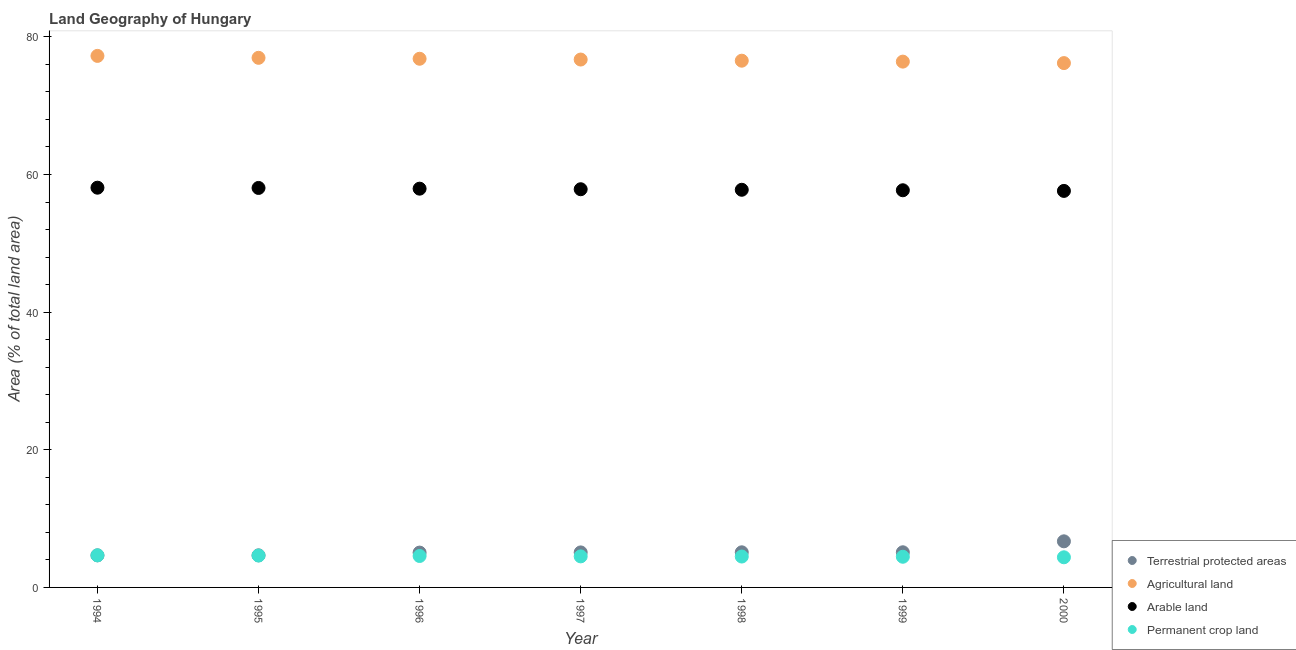How many different coloured dotlines are there?
Ensure brevity in your answer.  4. What is the percentage of land under terrestrial protection in 1996?
Your answer should be very brief. 5.06. Across all years, what is the maximum percentage of land under terrestrial protection?
Give a very brief answer. 6.7. Across all years, what is the minimum percentage of area under permanent crop land?
Your response must be concise. 4.38. What is the total percentage of area under agricultural land in the graph?
Offer a terse response. 536.87. What is the difference between the percentage of area under arable land in 1994 and that in 1996?
Your answer should be compact. 0.14. What is the difference between the percentage of area under arable land in 1994 and the percentage of area under permanent crop land in 2000?
Offer a very short reply. 53.71. What is the average percentage of area under agricultural land per year?
Ensure brevity in your answer.  76.7. In the year 1996, what is the difference between the percentage of land under terrestrial protection and percentage of area under agricultural land?
Provide a short and direct response. -71.76. What is the ratio of the percentage of area under permanent crop land in 1994 to that in 1998?
Make the answer very short. 1.04. What is the difference between the highest and the second highest percentage of area under arable land?
Your answer should be very brief. 0.04. What is the difference between the highest and the lowest percentage of land under terrestrial protection?
Your answer should be very brief. 2.04. In how many years, is the percentage of area under permanent crop land greater than the average percentage of area under permanent crop land taken over all years?
Your response must be concise. 3. Is the sum of the percentage of area under agricultural land in 1995 and 2000 greater than the maximum percentage of area under arable land across all years?
Make the answer very short. Yes. Is the percentage of land under terrestrial protection strictly greater than the percentage of area under permanent crop land over the years?
Ensure brevity in your answer.  No. Is the percentage of land under terrestrial protection strictly less than the percentage of area under permanent crop land over the years?
Give a very brief answer. No. What is the difference between two consecutive major ticks on the Y-axis?
Offer a very short reply. 20. How are the legend labels stacked?
Make the answer very short. Vertical. What is the title of the graph?
Your answer should be very brief. Land Geography of Hungary. What is the label or title of the Y-axis?
Make the answer very short. Area (% of total land area). What is the Area (% of total land area) of Terrestrial protected areas in 1994?
Ensure brevity in your answer.  4.66. What is the Area (% of total land area) in Agricultural land in 1994?
Your response must be concise. 77.24. What is the Area (% of total land area) in Arable land in 1994?
Your response must be concise. 58.09. What is the Area (% of total land area) in Permanent crop land in 1994?
Offer a terse response. 4.67. What is the Area (% of total land area) of Terrestrial protected areas in 1995?
Ensure brevity in your answer.  4.66. What is the Area (% of total land area) in Agricultural land in 1995?
Offer a terse response. 76.96. What is the Area (% of total land area) in Arable land in 1995?
Make the answer very short. 58.05. What is the Area (% of total land area) in Permanent crop land in 1995?
Keep it short and to the point. 4.63. What is the Area (% of total land area) in Terrestrial protected areas in 1996?
Give a very brief answer. 5.06. What is the Area (% of total land area) of Agricultural land in 1996?
Offer a very short reply. 76.82. What is the Area (% of total land area) in Arable land in 1996?
Your response must be concise. 57.94. What is the Area (% of total land area) of Permanent crop land in 1996?
Ensure brevity in your answer.  4.57. What is the Area (% of total land area) of Terrestrial protected areas in 1997?
Offer a very short reply. 5.09. What is the Area (% of total land area) of Agricultural land in 1997?
Provide a succinct answer. 76.71. What is the Area (% of total land area) of Arable land in 1997?
Keep it short and to the point. 57.86. What is the Area (% of total land area) of Permanent crop land in 1997?
Make the answer very short. 4.51. What is the Area (% of total land area) of Terrestrial protected areas in 1998?
Ensure brevity in your answer.  5.1. What is the Area (% of total land area) in Agricultural land in 1998?
Give a very brief answer. 76.54. What is the Area (% of total land area) in Arable land in 1998?
Offer a terse response. 57.78. What is the Area (% of total land area) in Permanent crop land in 1998?
Offer a terse response. 4.49. What is the Area (% of total land area) in Terrestrial protected areas in 1999?
Ensure brevity in your answer.  5.11. What is the Area (% of total land area) of Agricultural land in 1999?
Provide a short and direct response. 76.41. What is the Area (% of total land area) of Arable land in 1999?
Keep it short and to the point. 57.71. What is the Area (% of total land area) in Permanent crop land in 1999?
Provide a succinct answer. 4.46. What is the Area (% of total land area) of Terrestrial protected areas in 2000?
Ensure brevity in your answer.  6.7. What is the Area (% of total land area) of Agricultural land in 2000?
Ensure brevity in your answer.  76.19. What is the Area (% of total land area) in Arable land in 2000?
Offer a terse response. 57.62. What is the Area (% of total land area) in Permanent crop land in 2000?
Make the answer very short. 4.38. Across all years, what is the maximum Area (% of total land area) of Terrestrial protected areas?
Offer a very short reply. 6.7. Across all years, what is the maximum Area (% of total land area) of Agricultural land?
Your response must be concise. 77.24. Across all years, what is the maximum Area (% of total land area) of Arable land?
Keep it short and to the point. 58.09. Across all years, what is the maximum Area (% of total land area) of Permanent crop land?
Keep it short and to the point. 4.67. Across all years, what is the minimum Area (% of total land area) of Terrestrial protected areas?
Give a very brief answer. 4.66. Across all years, what is the minimum Area (% of total land area) of Agricultural land?
Make the answer very short. 76.19. Across all years, what is the minimum Area (% of total land area) of Arable land?
Your answer should be very brief. 57.62. Across all years, what is the minimum Area (% of total land area) of Permanent crop land?
Ensure brevity in your answer.  4.38. What is the total Area (% of total land area) in Terrestrial protected areas in the graph?
Offer a terse response. 36.39. What is the total Area (% of total land area) in Agricultural land in the graph?
Your answer should be very brief. 536.87. What is the total Area (% of total land area) in Arable land in the graph?
Keep it short and to the point. 405.06. What is the total Area (% of total land area) in Permanent crop land in the graph?
Provide a short and direct response. 31.7. What is the difference between the Area (% of total land area) in Terrestrial protected areas in 1994 and that in 1995?
Your response must be concise. -0. What is the difference between the Area (% of total land area) of Agricultural land in 1994 and that in 1995?
Offer a very short reply. 0.28. What is the difference between the Area (% of total land area) in Arable land in 1994 and that in 1995?
Your answer should be compact. 0.04. What is the difference between the Area (% of total land area) of Permanent crop land in 1994 and that in 1995?
Make the answer very short. 0.03. What is the difference between the Area (% of total land area) in Terrestrial protected areas in 1994 and that in 1996?
Provide a succinct answer. -0.4. What is the difference between the Area (% of total land area) of Agricultural land in 1994 and that in 1996?
Ensure brevity in your answer.  0.42. What is the difference between the Area (% of total land area) in Arable land in 1994 and that in 1996?
Keep it short and to the point. 0.14. What is the difference between the Area (% of total land area) of Permanent crop land in 1994 and that in 1996?
Give a very brief answer. 0.1. What is the difference between the Area (% of total land area) of Terrestrial protected areas in 1994 and that in 1997?
Make the answer very short. -0.43. What is the difference between the Area (% of total land area) of Agricultural land in 1994 and that in 1997?
Make the answer very short. 0.53. What is the difference between the Area (% of total land area) of Arable land in 1994 and that in 1997?
Offer a terse response. 0.23. What is the difference between the Area (% of total land area) of Permanent crop land in 1994 and that in 1997?
Your answer should be compact. 0.15. What is the difference between the Area (% of total land area) in Terrestrial protected areas in 1994 and that in 1998?
Offer a terse response. -0.44. What is the difference between the Area (% of total land area) of Agricultural land in 1994 and that in 1998?
Your answer should be compact. 0.7. What is the difference between the Area (% of total land area) in Arable land in 1994 and that in 1998?
Offer a terse response. 0.3. What is the difference between the Area (% of total land area) in Permanent crop land in 1994 and that in 1998?
Your answer should be compact. 0.18. What is the difference between the Area (% of total land area) of Terrestrial protected areas in 1994 and that in 1999?
Keep it short and to the point. -0.45. What is the difference between the Area (% of total land area) in Agricultural land in 1994 and that in 1999?
Keep it short and to the point. 0.83. What is the difference between the Area (% of total land area) of Arable land in 1994 and that in 1999?
Offer a very short reply. 0.37. What is the difference between the Area (% of total land area) of Permanent crop land in 1994 and that in 1999?
Offer a terse response. 0.21. What is the difference between the Area (% of total land area) in Terrestrial protected areas in 1994 and that in 2000?
Your answer should be very brief. -2.04. What is the difference between the Area (% of total land area) in Agricultural land in 1994 and that in 2000?
Offer a terse response. 1.05. What is the difference between the Area (% of total land area) in Arable land in 1994 and that in 2000?
Your response must be concise. 0.47. What is the difference between the Area (% of total land area) of Permanent crop land in 1994 and that in 2000?
Offer a terse response. 0.29. What is the difference between the Area (% of total land area) in Terrestrial protected areas in 1995 and that in 1996?
Provide a short and direct response. -0.4. What is the difference between the Area (% of total land area) in Agricultural land in 1995 and that in 1996?
Provide a short and direct response. 0.14. What is the difference between the Area (% of total land area) of Arable land in 1995 and that in 1996?
Your response must be concise. 0.1. What is the difference between the Area (% of total land area) of Permanent crop land in 1995 and that in 1996?
Keep it short and to the point. 0.07. What is the difference between the Area (% of total land area) in Terrestrial protected areas in 1995 and that in 1997?
Make the answer very short. -0.43. What is the difference between the Area (% of total land area) in Agricultural land in 1995 and that in 1997?
Keep it short and to the point. 0.25. What is the difference between the Area (% of total land area) of Arable land in 1995 and that in 1997?
Offer a very short reply. 0.19. What is the difference between the Area (% of total land area) of Permanent crop land in 1995 and that in 1997?
Offer a very short reply. 0.12. What is the difference between the Area (% of total land area) in Terrestrial protected areas in 1995 and that in 1998?
Ensure brevity in your answer.  -0.44. What is the difference between the Area (% of total land area) in Agricultural land in 1995 and that in 1998?
Offer a terse response. 0.42. What is the difference between the Area (% of total land area) in Arable land in 1995 and that in 1998?
Your answer should be very brief. 0.26. What is the difference between the Area (% of total land area) in Permanent crop land in 1995 and that in 1998?
Make the answer very short. 0.14. What is the difference between the Area (% of total land area) of Terrestrial protected areas in 1995 and that in 1999?
Your answer should be very brief. -0.44. What is the difference between the Area (% of total land area) of Agricultural land in 1995 and that in 1999?
Offer a very short reply. 0.55. What is the difference between the Area (% of total land area) of Arable land in 1995 and that in 1999?
Ensure brevity in your answer.  0.34. What is the difference between the Area (% of total land area) of Permanent crop land in 1995 and that in 1999?
Offer a terse response. 0.18. What is the difference between the Area (% of total land area) in Terrestrial protected areas in 1995 and that in 2000?
Offer a very short reply. -2.04. What is the difference between the Area (% of total land area) of Agricultural land in 1995 and that in 2000?
Offer a very short reply. 0.77. What is the difference between the Area (% of total land area) in Arable land in 1995 and that in 2000?
Your answer should be compact. 0.43. What is the difference between the Area (% of total land area) in Permanent crop land in 1995 and that in 2000?
Make the answer very short. 0.25. What is the difference between the Area (% of total land area) in Terrestrial protected areas in 1996 and that in 1997?
Make the answer very short. -0.03. What is the difference between the Area (% of total land area) in Agricultural land in 1996 and that in 1997?
Your answer should be very brief. 0.11. What is the difference between the Area (% of total land area) in Arable land in 1996 and that in 1997?
Ensure brevity in your answer.  0.08. What is the difference between the Area (% of total land area) of Permanent crop land in 1996 and that in 1997?
Make the answer very short. 0.06. What is the difference between the Area (% of total land area) of Terrestrial protected areas in 1996 and that in 1998?
Offer a very short reply. -0.04. What is the difference between the Area (% of total land area) of Agricultural land in 1996 and that in 1998?
Your answer should be very brief. 0.28. What is the difference between the Area (% of total land area) of Arable land in 1996 and that in 1998?
Your answer should be very brief. 0.16. What is the difference between the Area (% of total land area) in Permanent crop land in 1996 and that in 1998?
Offer a very short reply. 0.08. What is the difference between the Area (% of total land area) of Terrestrial protected areas in 1996 and that in 1999?
Make the answer very short. -0.04. What is the difference between the Area (% of total land area) in Agricultural land in 1996 and that in 1999?
Offer a terse response. 0.42. What is the difference between the Area (% of total land area) in Arable land in 1996 and that in 1999?
Provide a short and direct response. 0.23. What is the difference between the Area (% of total land area) in Permanent crop land in 1996 and that in 1999?
Your answer should be compact. 0.11. What is the difference between the Area (% of total land area) in Terrestrial protected areas in 1996 and that in 2000?
Your answer should be compact. -1.64. What is the difference between the Area (% of total land area) in Agricultural land in 1996 and that in 2000?
Offer a very short reply. 0.63. What is the difference between the Area (% of total land area) in Arable land in 1996 and that in 2000?
Give a very brief answer. 0.33. What is the difference between the Area (% of total land area) of Permanent crop land in 1996 and that in 2000?
Your answer should be compact. 0.19. What is the difference between the Area (% of total land area) in Terrestrial protected areas in 1997 and that in 1998?
Give a very brief answer. -0.01. What is the difference between the Area (% of total land area) in Arable land in 1997 and that in 1998?
Keep it short and to the point. 0.08. What is the difference between the Area (% of total land area) in Permanent crop land in 1997 and that in 1998?
Offer a terse response. 0.02. What is the difference between the Area (% of total land area) of Terrestrial protected areas in 1997 and that in 1999?
Give a very brief answer. -0.02. What is the difference between the Area (% of total land area) of Agricultural land in 1997 and that in 1999?
Give a very brief answer. 0.3. What is the difference between the Area (% of total land area) of Arable land in 1997 and that in 1999?
Your answer should be compact. 0.15. What is the difference between the Area (% of total land area) of Permanent crop land in 1997 and that in 1999?
Your answer should be compact. 0.06. What is the difference between the Area (% of total land area) of Terrestrial protected areas in 1997 and that in 2000?
Give a very brief answer. -1.61. What is the difference between the Area (% of total land area) of Agricultural land in 1997 and that in 2000?
Offer a terse response. 0.52. What is the difference between the Area (% of total land area) in Arable land in 1997 and that in 2000?
Your answer should be compact. 0.24. What is the difference between the Area (% of total land area) of Permanent crop land in 1997 and that in 2000?
Provide a short and direct response. 0.13. What is the difference between the Area (% of total land area) in Terrestrial protected areas in 1998 and that in 1999?
Your answer should be very brief. -0. What is the difference between the Area (% of total land area) of Agricultural land in 1998 and that in 1999?
Ensure brevity in your answer.  0.14. What is the difference between the Area (% of total land area) of Arable land in 1998 and that in 1999?
Offer a very short reply. 0.07. What is the difference between the Area (% of total land area) of Permanent crop land in 1998 and that in 1999?
Your answer should be compact. 0.03. What is the difference between the Area (% of total land area) in Terrestrial protected areas in 1998 and that in 2000?
Make the answer very short. -1.6. What is the difference between the Area (% of total land area) in Agricultural land in 1998 and that in 2000?
Your response must be concise. 0.35. What is the difference between the Area (% of total land area) in Arable land in 1998 and that in 2000?
Provide a succinct answer. 0.17. What is the difference between the Area (% of total land area) in Permanent crop land in 1998 and that in 2000?
Your answer should be very brief. 0.11. What is the difference between the Area (% of total land area) in Terrestrial protected areas in 1999 and that in 2000?
Provide a succinct answer. -1.59. What is the difference between the Area (% of total land area) in Agricultural land in 1999 and that in 2000?
Make the answer very short. 0.21. What is the difference between the Area (% of total land area) of Arable land in 1999 and that in 2000?
Ensure brevity in your answer.  0.09. What is the difference between the Area (% of total land area) in Permanent crop land in 1999 and that in 2000?
Keep it short and to the point. 0.08. What is the difference between the Area (% of total land area) of Terrestrial protected areas in 1994 and the Area (% of total land area) of Agricultural land in 1995?
Your answer should be very brief. -72.3. What is the difference between the Area (% of total land area) of Terrestrial protected areas in 1994 and the Area (% of total land area) of Arable land in 1995?
Offer a terse response. -53.39. What is the difference between the Area (% of total land area) of Terrestrial protected areas in 1994 and the Area (% of total land area) of Permanent crop land in 1995?
Give a very brief answer. 0.03. What is the difference between the Area (% of total land area) in Agricultural land in 1994 and the Area (% of total land area) in Arable land in 1995?
Offer a terse response. 19.19. What is the difference between the Area (% of total land area) in Agricultural land in 1994 and the Area (% of total land area) in Permanent crop land in 1995?
Your answer should be very brief. 72.61. What is the difference between the Area (% of total land area) of Arable land in 1994 and the Area (% of total land area) of Permanent crop land in 1995?
Give a very brief answer. 53.45. What is the difference between the Area (% of total land area) in Terrestrial protected areas in 1994 and the Area (% of total land area) in Agricultural land in 1996?
Provide a succinct answer. -72.16. What is the difference between the Area (% of total land area) in Terrestrial protected areas in 1994 and the Area (% of total land area) in Arable land in 1996?
Keep it short and to the point. -53.28. What is the difference between the Area (% of total land area) of Terrestrial protected areas in 1994 and the Area (% of total land area) of Permanent crop land in 1996?
Keep it short and to the point. 0.09. What is the difference between the Area (% of total land area) of Agricultural land in 1994 and the Area (% of total land area) of Arable land in 1996?
Offer a terse response. 19.29. What is the difference between the Area (% of total land area) in Agricultural land in 1994 and the Area (% of total land area) in Permanent crop land in 1996?
Keep it short and to the point. 72.67. What is the difference between the Area (% of total land area) of Arable land in 1994 and the Area (% of total land area) of Permanent crop land in 1996?
Provide a short and direct response. 53.52. What is the difference between the Area (% of total land area) of Terrestrial protected areas in 1994 and the Area (% of total land area) of Agricultural land in 1997?
Offer a terse response. -72.05. What is the difference between the Area (% of total land area) of Terrestrial protected areas in 1994 and the Area (% of total land area) of Arable land in 1997?
Give a very brief answer. -53.2. What is the difference between the Area (% of total land area) in Terrestrial protected areas in 1994 and the Area (% of total land area) in Permanent crop land in 1997?
Make the answer very short. 0.15. What is the difference between the Area (% of total land area) of Agricultural land in 1994 and the Area (% of total land area) of Arable land in 1997?
Offer a terse response. 19.38. What is the difference between the Area (% of total land area) of Agricultural land in 1994 and the Area (% of total land area) of Permanent crop land in 1997?
Your answer should be very brief. 72.73. What is the difference between the Area (% of total land area) of Arable land in 1994 and the Area (% of total land area) of Permanent crop land in 1997?
Ensure brevity in your answer.  53.58. What is the difference between the Area (% of total land area) in Terrestrial protected areas in 1994 and the Area (% of total land area) in Agricultural land in 1998?
Offer a very short reply. -71.88. What is the difference between the Area (% of total land area) of Terrestrial protected areas in 1994 and the Area (% of total land area) of Arable land in 1998?
Provide a short and direct response. -53.12. What is the difference between the Area (% of total land area) in Terrestrial protected areas in 1994 and the Area (% of total land area) in Permanent crop land in 1998?
Offer a terse response. 0.17. What is the difference between the Area (% of total land area) in Agricultural land in 1994 and the Area (% of total land area) in Arable land in 1998?
Make the answer very short. 19.45. What is the difference between the Area (% of total land area) of Agricultural land in 1994 and the Area (% of total land area) of Permanent crop land in 1998?
Ensure brevity in your answer.  72.75. What is the difference between the Area (% of total land area) of Arable land in 1994 and the Area (% of total land area) of Permanent crop land in 1998?
Offer a terse response. 53.6. What is the difference between the Area (% of total land area) of Terrestrial protected areas in 1994 and the Area (% of total land area) of Agricultural land in 1999?
Provide a succinct answer. -71.74. What is the difference between the Area (% of total land area) of Terrestrial protected areas in 1994 and the Area (% of total land area) of Arable land in 1999?
Your response must be concise. -53.05. What is the difference between the Area (% of total land area) of Terrestrial protected areas in 1994 and the Area (% of total land area) of Permanent crop land in 1999?
Offer a very short reply. 0.2. What is the difference between the Area (% of total land area) of Agricultural land in 1994 and the Area (% of total land area) of Arable land in 1999?
Provide a succinct answer. 19.53. What is the difference between the Area (% of total land area) of Agricultural land in 1994 and the Area (% of total land area) of Permanent crop land in 1999?
Provide a short and direct response. 72.78. What is the difference between the Area (% of total land area) of Arable land in 1994 and the Area (% of total land area) of Permanent crop land in 1999?
Ensure brevity in your answer.  53.63. What is the difference between the Area (% of total land area) in Terrestrial protected areas in 1994 and the Area (% of total land area) in Agricultural land in 2000?
Provide a short and direct response. -71.53. What is the difference between the Area (% of total land area) of Terrestrial protected areas in 1994 and the Area (% of total land area) of Arable land in 2000?
Give a very brief answer. -52.96. What is the difference between the Area (% of total land area) of Terrestrial protected areas in 1994 and the Area (% of total land area) of Permanent crop land in 2000?
Keep it short and to the point. 0.28. What is the difference between the Area (% of total land area) in Agricultural land in 1994 and the Area (% of total land area) in Arable land in 2000?
Offer a terse response. 19.62. What is the difference between the Area (% of total land area) in Agricultural land in 1994 and the Area (% of total land area) in Permanent crop land in 2000?
Give a very brief answer. 72.86. What is the difference between the Area (% of total land area) in Arable land in 1994 and the Area (% of total land area) in Permanent crop land in 2000?
Ensure brevity in your answer.  53.71. What is the difference between the Area (% of total land area) of Terrestrial protected areas in 1995 and the Area (% of total land area) of Agricultural land in 1996?
Ensure brevity in your answer.  -72.16. What is the difference between the Area (% of total land area) in Terrestrial protected areas in 1995 and the Area (% of total land area) in Arable land in 1996?
Offer a terse response. -53.28. What is the difference between the Area (% of total land area) in Terrestrial protected areas in 1995 and the Area (% of total land area) in Permanent crop land in 1996?
Give a very brief answer. 0.1. What is the difference between the Area (% of total land area) in Agricultural land in 1995 and the Area (% of total land area) in Arable land in 1996?
Keep it short and to the point. 19.01. What is the difference between the Area (% of total land area) of Agricultural land in 1995 and the Area (% of total land area) of Permanent crop land in 1996?
Offer a terse response. 72.39. What is the difference between the Area (% of total land area) of Arable land in 1995 and the Area (% of total land area) of Permanent crop land in 1996?
Keep it short and to the point. 53.48. What is the difference between the Area (% of total land area) of Terrestrial protected areas in 1995 and the Area (% of total land area) of Agricultural land in 1997?
Your answer should be very brief. -72.05. What is the difference between the Area (% of total land area) of Terrestrial protected areas in 1995 and the Area (% of total land area) of Arable land in 1997?
Ensure brevity in your answer.  -53.2. What is the difference between the Area (% of total land area) of Terrestrial protected areas in 1995 and the Area (% of total land area) of Permanent crop land in 1997?
Provide a short and direct response. 0.15. What is the difference between the Area (% of total land area) in Agricultural land in 1995 and the Area (% of total land area) in Arable land in 1997?
Your response must be concise. 19.1. What is the difference between the Area (% of total land area) in Agricultural land in 1995 and the Area (% of total land area) in Permanent crop land in 1997?
Provide a short and direct response. 72.45. What is the difference between the Area (% of total land area) of Arable land in 1995 and the Area (% of total land area) of Permanent crop land in 1997?
Your answer should be compact. 53.54. What is the difference between the Area (% of total land area) of Terrestrial protected areas in 1995 and the Area (% of total land area) of Agricultural land in 1998?
Ensure brevity in your answer.  -71.88. What is the difference between the Area (% of total land area) of Terrestrial protected areas in 1995 and the Area (% of total land area) of Arable land in 1998?
Keep it short and to the point. -53.12. What is the difference between the Area (% of total land area) of Terrestrial protected areas in 1995 and the Area (% of total land area) of Permanent crop land in 1998?
Give a very brief answer. 0.17. What is the difference between the Area (% of total land area) of Agricultural land in 1995 and the Area (% of total land area) of Arable land in 1998?
Your answer should be very brief. 19.17. What is the difference between the Area (% of total land area) in Agricultural land in 1995 and the Area (% of total land area) in Permanent crop land in 1998?
Offer a terse response. 72.47. What is the difference between the Area (% of total land area) in Arable land in 1995 and the Area (% of total land area) in Permanent crop land in 1998?
Give a very brief answer. 53.56. What is the difference between the Area (% of total land area) of Terrestrial protected areas in 1995 and the Area (% of total land area) of Agricultural land in 1999?
Your response must be concise. -71.74. What is the difference between the Area (% of total land area) of Terrestrial protected areas in 1995 and the Area (% of total land area) of Arable land in 1999?
Keep it short and to the point. -53.05. What is the difference between the Area (% of total land area) of Terrestrial protected areas in 1995 and the Area (% of total land area) of Permanent crop land in 1999?
Ensure brevity in your answer.  0.21. What is the difference between the Area (% of total land area) of Agricultural land in 1995 and the Area (% of total land area) of Arable land in 1999?
Provide a short and direct response. 19.25. What is the difference between the Area (% of total land area) of Agricultural land in 1995 and the Area (% of total land area) of Permanent crop land in 1999?
Your response must be concise. 72.5. What is the difference between the Area (% of total land area) in Arable land in 1995 and the Area (% of total land area) in Permanent crop land in 1999?
Your answer should be compact. 53.59. What is the difference between the Area (% of total land area) of Terrestrial protected areas in 1995 and the Area (% of total land area) of Agricultural land in 2000?
Keep it short and to the point. -71.53. What is the difference between the Area (% of total land area) in Terrestrial protected areas in 1995 and the Area (% of total land area) in Arable land in 2000?
Make the answer very short. -52.96. What is the difference between the Area (% of total land area) of Terrestrial protected areas in 1995 and the Area (% of total land area) of Permanent crop land in 2000?
Your response must be concise. 0.28. What is the difference between the Area (% of total land area) in Agricultural land in 1995 and the Area (% of total land area) in Arable land in 2000?
Your answer should be very brief. 19.34. What is the difference between the Area (% of total land area) of Agricultural land in 1995 and the Area (% of total land area) of Permanent crop land in 2000?
Make the answer very short. 72.58. What is the difference between the Area (% of total land area) in Arable land in 1995 and the Area (% of total land area) in Permanent crop land in 2000?
Provide a short and direct response. 53.67. What is the difference between the Area (% of total land area) in Terrestrial protected areas in 1996 and the Area (% of total land area) in Agricultural land in 1997?
Keep it short and to the point. -71.65. What is the difference between the Area (% of total land area) of Terrestrial protected areas in 1996 and the Area (% of total land area) of Arable land in 1997?
Provide a short and direct response. -52.8. What is the difference between the Area (% of total land area) of Terrestrial protected areas in 1996 and the Area (% of total land area) of Permanent crop land in 1997?
Provide a succinct answer. 0.55. What is the difference between the Area (% of total land area) of Agricultural land in 1996 and the Area (% of total land area) of Arable land in 1997?
Ensure brevity in your answer.  18.96. What is the difference between the Area (% of total land area) in Agricultural land in 1996 and the Area (% of total land area) in Permanent crop land in 1997?
Ensure brevity in your answer.  72.31. What is the difference between the Area (% of total land area) of Arable land in 1996 and the Area (% of total land area) of Permanent crop land in 1997?
Make the answer very short. 53.43. What is the difference between the Area (% of total land area) in Terrestrial protected areas in 1996 and the Area (% of total land area) in Agricultural land in 1998?
Your answer should be compact. -71.48. What is the difference between the Area (% of total land area) of Terrestrial protected areas in 1996 and the Area (% of total land area) of Arable land in 1998?
Your answer should be compact. -52.72. What is the difference between the Area (% of total land area) of Terrestrial protected areas in 1996 and the Area (% of total land area) of Permanent crop land in 1998?
Your response must be concise. 0.57. What is the difference between the Area (% of total land area) in Agricultural land in 1996 and the Area (% of total land area) in Arable land in 1998?
Give a very brief answer. 19.04. What is the difference between the Area (% of total land area) of Agricultural land in 1996 and the Area (% of total land area) of Permanent crop land in 1998?
Provide a succinct answer. 72.33. What is the difference between the Area (% of total land area) in Arable land in 1996 and the Area (% of total land area) in Permanent crop land in 1998?
Your answer should be compact. 53.46. What is the difference between the Area (% of total land area) in Terrestrial protected areas in 1996 and the Area (% of total land area) in Agricultural land in 1999?
Your answer should be compact. -71.34. What is the difference between the Area (% of total land area) in Terrestrial protected areas in 1996 and the Area (% of total land area) in Arable land in 1999?
Your answer should be very brief. -52.65. What is the difference between the Area (% of total land area) of Terrestrial protected areas in 1996 and the Area (% of total land area) of Permanent crop land in 1999?
Keep it short and to the point. 0.61. What is the difference between the Area (% of total land area) of Agricultural land in 1996 and the Area (% of total land area) of Arable land in 1999?
Offer a terse response. 19.11. What is the difference between the Area (% of total land area) of Agricultural land in 1996 and the Area (% of total land area) of Permanent crop land in 1999?
Give a very brief answer. 72.37. What is the difference between the Area (% of total land area) of Arable land in 1996 and the Area (% of total land area) of Permanent crop land in 1999?
Ensure brevity in your answer.  53.49. What is the difference between the Area (% of total land area) of Terrestrial protected areas in 1996 and the Area (% of total land area) of Agricultural land in 2000?
Make the answer very short. -71.13. What is the difference between the Area (% of total land area) of Terrestrial protected areas in 1996 and the Area (% of total land area) of Arable land in 2000?
Your answer should be compact. -52.56. What is the difference between the Area (% of total land area) of Terrestrial protected areas in 1996 and the Area (% of total land area) of Permanent crop land in 2000?
Ensure brevity in your answer.  0.68. What is the difference between the Area (% of total land area) in Agricultural land in 1996 and the Area (% of total land area) in Arable land in 2000?
Your answer should be very brief. 19.2. What is the difference between the Area (% of total land area) in Agricultural land in 1996 and the Area (% of total land area) in Permanent crop land in 2000?
Make the answer very short. 72.44. What is the difference between the Area (% of total land area) in Arable land in 1996 and the Area (% of total land area) in Permanent crop land in 2000?
Your answer should be compact. 53.57. What is the difference between the Area (% of total land area) of Terrestrial protected areas in 1997 and the Area (% of total land area) of Agricultural land in 1998?
Offer a very short reply. -71.45. What is the difference between the Area (% of total land area) in Terrestrial protected areas in 1997 and the Area (% of total land area) in Arable land in 1998?
Offer a terse response. -52.7. What is the difference between the Area (% of total land area) in Terrestrial protected areas in 1997 and the Area (% of total land area) in Permanent crop land in 1998?
Give a very brief answer. 0.6. What is the difference between the Area (% of total land area) of Agricultural land in 1997 and the Area (% of total land area) of Arable land in 1998?
Offer a very short reply. 18.92. What is the difference between the Area (% of total land area) in Agricultural land in 1997 and the Area (% of total land area) in Permanent crop land in 1998?
Offer a terse response. 72.22. What is the difference between the Area (% of total land area) in Arable land in 1997 and the Area (% of total land area) in Permanent crop land in 1998?
Your answer should be very brief. 53.37. What is the difference between the Area (% of total land area) of Terrestrial protected areas in 1997 and the Area (% of total land area) of Agricultural land in 1999?
Make the answer very short. -71.32. What is the difference between the Area (% of total land area) in Terrestrial protected areas in 1997 and the Area (% of total land area) in Arable land in 1999?
Your response must be concise. -52.62. What is the difference between the Area (% of total land area) in Terrestrial protected areas in 1997 and the Area (% of total land area) in Permanent crop land in 1999?
Offer a very short reply. 0.63. What is the difference between the Area (% of total land area) in Agricultural land in 1997 and the Area (% of total land area) in Arable land in 1999?
Provide a short and direct response. 19. What is the difference between the Area (% of total land area) of Agricultural land in 1997 and the Area (% of total land area) of Permanent crop land in 1999?
Your response must be concise. 72.25. What is the difference between the Area (% of total land area) of Arable land in 1997 and the Area (% of total land area) of Permanent crop land in 1999?
Give a very brief answer. 53.41. What is the difference between the Area (% of total land area) in Terrestrial protected areas in 1997 and the Area (% of total land area) in Agricultural land in 2000?
Keep it short and to the point. -71.1. What is the difference between the Area (% of total land area) of Terrestrial protected areas in 1997 and the Area (% of total land area) of Arable land in 2000?
Your answer should be compact. -52.53. What is the difference between the Area (% of total land area) in Terrestrial protected areas in 1997 and the Area (% of total land area) in Permanent crop land in 2000?
Your response must be concise. 0.71. What is the difference between the Area (% of total land area) in Agricultural land in 1997 and the Area (% of total land area) in Arable land in 2000?
Provide a succinct answer. 19.09. What is the difference between the Area (% of total land area) in Agricultural land in 1997 and the Area (% of total land area) in Permanent crop land in 2000?
Your answer should be very brief. 72.33. What is the difference between the Area (% of total land area) in Arable land in 1997 and the Area (% of total land area) in Permanent crop land in 2000?
Your response must be concise. 53.48. What is the difference between the Area (% of total land area) of Terrestrial protected areas in 1998 and the Area (% of total land area) of Agricultural land in 1999?
Give a very brief answer. -71.3. What is the difference between the Area (% of total land area) in Terrestrial protected areas in 1998 and the Area (% of total land area) in Arable land in 1999?
Your answer should be compact. -52.61. What is the difference between the Area (% of total land area) of Terrestrial protected areas in 1998 and the Area (% of total land area) of Permanent crop land in 1999?
Offer a terse response. 0.65. What is the difference between the Area (% of total land area) of Agricultural land in 1998 and the Area (% of total land area) of Arable land in 1999?
Your response must be concise. 18.83. What is the difference between the Area (% of total land area) of Agricultural land in 1998 and the Area (% of total land area) of Permanent crop land in 1999?
Make the answer very short. 72.09. What is the difference between the Area (% of total land area) of Arable land in 1998 and the Area (% of total land area) of Permanent crop land in 1999?
Provide a short and direct response. 53.33. What is the difference between the Area (% of total land area) in Terrestrial protected areas in 1998 and the Area (% of total land area) in Agricultural land in 2000?
Ensure brevity in your answer.  -71.09. What is the difference between the Area (% of total land area) in Terrestrial protected areas in 1998 and the Area (% of total land area) in Arable land in 2000?
Offer a very short reply. -52.52. What is the difference between the Area (% of total land area) of Terrestrial protected areas in 1998 and the Area (% of total land area) of Permanent crop land in 2000?
Ensure brevity in your answer.  0.72. What is the difference between the Area (% of total land area) in Agricultural land in 1998 and the Area (% of total land area) in Arable land in 2000?
Provide a succinct answer. 18.92. What is the difference between the Area (% of total land area) in Agricultural land in 1998 and the Area (% of total land area) in Permanent crop land in 2000?
Your answer should be very brief. 72.16. What is the difference between the Area (% of total land area) of Arable land in 1998 and the Area (% of total land area) of Permanent crop land in 2000?
Make the answer very short. 53.41. What is the difference between the Area (% of total land area) in Terrestrial protected areas in 1999 and the Area (% of total land area) in Agricultural land in 2000?
Your response must be concise. -71.08. What is the difference between the Area (% of total land area) in Terrestrial protected areas in 1999 and the Area (% of total land area) in Arable land in 2000?
Provide a short and direct response. -52.51. What is the difference between the Area (% of total land area) in Terrestrial protected areas in 1999 and the Area (% of total land area) in Permanent crop land in 2000?
Make the answer very short. 0.73. What is the difference between the Area (% of total land area) in Agricultural land in 1999 and the Area (% of total land area) in Arable land in 2000?
Provide a succinct answer. 18.79. What is the difference between the Area (% of total land area) in Agricultural land in 1999 and the Area (% of total land area) in Permanent crop land in 2000?
Provide a succinct answer. 72.03. What is the difference between the Area (% of total land area) of Arable land in 1999 and the Area (% of total land area) of Permanent crop land in 2000?
Your answer should be compact. 53.33. What is the average Area (% of total land area) in Terrestrial protected areas per year?
Provide a succinct answer. 5.2. What is the average Area (% of total land area) in Agricultural land per year?
Your answer should be very brief. 76.7. What is the average Area (% of total land area) of Arable land per year?
Your response must be concise. 57.87. What is the average Area (% of total land area) of Permanent crop land per year?
Ensure brevity in your answer.  4.53. In the year 1994, what is the difference between the Area (% of total land area) of Terrestrial protected areas and Area (% of total land area) of Agricultural land?
Ensure brevity in your answer.  -72.58. In the year 1994, what is the difference between the Area (% of total land area) of Terrestrial protected areas and Area (% of total land area) of Arable land?
Your answer should be very brief. -53.43. In the year 1994, what is the difference between the Area (% of total land area) in Terrestrial protected areas and Area (% of total land area) in Permanent crop land?
Offer a terse response. -0. In the year 1994, what is the difference between the Area (% of total land area) in Agricultural land and Area (% of total land area) in Arable land?
Keep it short and to the point. 19.15. In the year 1994, what is the difference between the Area (% of total land area) of Agricultural land and Area (% of total land area) of Permanent crop land?
Ensure brevity in your answer.  72.57. In the year 1994, what is the difference between the Area (% of total land area) of Arable land and Area (% of total land area) of Permanent crop land?
Make the answer very short. 53.42. In the year 1995, what is the difference between the Area (% of total land area) in Terrestrial protected areas and Area (% of total land area) in Agricultural land?
Give a very brief answer. -72.3. In the year 1995, what is the difference between the Area (% of total land area) in Terrestrial protected areas and Area (% of total land area) in Arable land?
Give a very brief answer. -53.39. In the year 1995, what is the difference between the Area (% of total land area) in Terrestrial protected areas and Area (% of total land area) in Permanent crop land?
Give a very brief answer. 0.03. In the year 1995, what is the difference between the Area (% of total land area) of Agricultural land and Area (% of total land area) of Arable land?
Keep it short and to the point. 18.91. In the year 1995, what is the difference between the Area (% of total land area) in Agricultural land and Area (% of total land area) in Permanent crop land?
Provide a short and direct response. 72.33. In the year 1995, what is the difference between the Area (% of total land area) of Arable land and Area (% of total land area) of Permanent crop land?
Offer a very short reply. 53.42. In the year 1996, what is the difference between the Area (% of total land area) of Terrestrial protected areas and Area (% of total land area) of Agricultural land?
Your response must be concise. -71.76. In the year 1996, what is the difference between the Area (% of total land area) of Terrestrial protected areas and Area (% of total land area) of Arable land?
Keep it short and to the point. -52.88. In the year 1996, what is the difference between the Area (% of total land area) of Terrestrial protected areas and Area (% of total land area) of Permanent crop land?
Provide a succinct answer. 0.5. In the year 1996, what is the difference between the Area (% of total land area) of Agricultural land and Area (% of total land area) of Arable land?
Offer a terse response. 18.88. In the year 1996, what is the difference between the Area (% of total land area) in Agricultural land and Area (% of total land area) in Permanent crop land?
Provide a short and direct response. 72.26. In the year 1996, what is the difference between the Area (% of total land area) in Arable land and Area (% of total land area) in Permanent crop land?
Offer a very short reply. 53.38. In the year 1997, what is the difference between the Area (% of total land area) of Terrestrial protected areas and Area (% of total land area) of Agricultural land?
Give a very brief answer. -71.62. In the year 1997, what is the difference between the Area (% of total land area) in Terrestrial protected areas and Area (% of total land area) in Arable land?
Keep it short and to the point. -52.77. In the year 1997, what is the difference between the Area (% of total land area) in Terrestrial protected areas and Area (% of total land area) in Permanent crop land?
Make the answer very short. 0.58. In the year 1997, what is the difference between the Area (% of total land area) in Agricultural land and Area (% of total land area) in Arable land?
Your answer should be very brief. 18.85. In the year 1997, what is the difference between the Area (% of total land area) of Agricultural land and Area (% of total land area) of Permanent crop land?
Your response must be concise. 72.2. In the year 1997, what is the difference between the Area (% of total land area) of Arable land and Area (% of total land area) of Permanent crop land?
Ensure brevity in your answer.  53.35. In the year 1998, what is the difference between the Area (% of total land area) in Terrestrial protected areas and Area (% of total land area) in Agricultural land?
Your answer should be very brief. -71.44. In the year 1998, what is the difference between the Area (% of total land area) of Terrestrial protected areas and Area (% of total land area) of Arable land?
Your answer should be very brief. -52.68. In the year 1998, what is the difference between the Area (% of total land area) in Terrestrial protected areas and Area (% of total land area) in Permanent crop land?
Ensure brevity in your answer.  0.61. In the year 1998, what is the difference between the Area (% of total land area) of Agricultural land and Area (% of total land area) of Arable land?
Your response must be concise. 18.76. In the year 1998, what is the difference between the Area (% of total land area) in Agricultural land and Area (% of total land area) in Permanent crop land?
Offer a very short reply. 72.05. In the year 1998, what is the difference between the Area (% of total land area) of Arable land and Area (% of total land area) of Permanent crop land?
Provide a short and direct response. 53.29. In the year 1999, what is the difference between the Area (% of total land area) of Terrestrial protected areas and Area (% of total land area) of Agricultural land?
Offer a very short reply. -71.3. In the year 1999, what is the difference between the Area (% of total land area) in Terrestrial protected areas and Area (% of total land area) in Arable land?
Your answer should be compact. -52.61. In the year 1999, what is the difference between the Area (% of total land area) of Terrestrial protected areas and Area (% of total land area) of Permanent crop land?
Make the answer very short. 0.65. In the year 1999, what is the difference between the Area (% of total land area) in Agricultural land and Area (% of total land area) in Arable land?
Your answer should be compact. 18.69. In the year 1999, what is the difference between the Area (% of total land area) of Agricultural land and Area (% of total land area) of Permanent crop land?
Ensure brevity in your answer.  71.95. In the year 1999, what is the difference between the Area (% of total land area) in Arable land and Area (% of total land area) in Permanent crop land?
Ensure brevity in your answer.  53.26. In the year 2000, what is the difference between the Area (% of total land area) in Terrestrial protected areas and Area (% of total land area) in Agricultural land?
Your response must be concise. -69.49. In the year 2000, what is the difference between the Area (% of total land area) of Terrestrial protected areas and Area (% of total land area) of Arable land?
Your response must be concise. -50.92. In the year 2000, what is the difference between the Area (% of total land area) in Terrestrial protected areas and Area (% of total land area) in Permanent crop land?
Make the answer very short. 2.32. In the year 2000, what is the difference between the Area (% of total land area) of Agricultural land and Area (% of total land area) of Arable land?
Ensure brevity in your answer.  18.57. In the year 2000, what is the difference between the Area (% of total land area) in Agricultural land and Area (% of total land area) in Permanent crop land?
Your response must be concise. 71.81. In the year 2000, what is the difference between the Area (% of total land area) in Arable land and Area (% of total land area) in Permanent crop land?
Provide a short and direct response. 53.24. What is the ratio of the Area (% of total land area) in Agricultural land in 1994 to that in 1995?
Your answer should be compact. 1. What is the ratio of the Area (% of total land area) in Permanent crop land in 1994 to that in 1995?
Provide a succinct answer. 1.01. What is the ratio of the Area (% of total land area) of Terrestrial protected areas in 1994 to that in 1996?
Give a very brief answer. 0.92. What is the ratio of the Area (% of total land area) of Agricultural land in 1994 to that in 1996?
Your response must be concise. 1.01. What is the ratio of the Area (% of total land area) of Arable land in 1994 to that in 1996?
Offer a terse response. 1. What is the ratio of the Area (% of total land area) of Permanent crop land in 1994 to that in 1996?
Your answer should be compact. 1.02. What is the ratio of the Area (% of total land area) of Terrestrial protected areas in 1994 to that in 1997?
Provide a short and direct response. 0.92. What is the ratio of the Area (% of total land area) of Arable land in 1994 to that in 1997?
Offer a terse response. 1. What is the ratio of the Area (% of total land area) of Permanent crop land in 1994 to that in 1997?
Ensure brevity in your answer.  1.03. What is the ratio of the Area (% of total land area) in Terrestrial protected areas in 1994 to that in 1998?
Provide a short and direct response. 0.91. What is the ratio of the Area (% of total land area) in Agricultural land in 1994 to that in 1998?
Your response must be concise. 1.01. What is the ratio of the Area (% of total land area) in Permanent crop land in 1994 to that in 1998?
Make the answer very short. 1.04. What is the ratio of the Area (% of total land area) in Terrestrial protected areas in 1994 to that in 1999?
Make the answer very short. 0.91. What is the ratio of the Area (% of total land area) in Agricultural land in 1994 to that in 1999?
Your answer should be very brief. 1.01. What is the ratio of the Area (% of total land area) in Arable land in 1994 to that in 1999?
Ensure brevity in your answer.  1.01. What is the ratio of the Area (% of total land area) in Permanent crop land in 1994 to that in 1999?
Give a very brief answer. 1.05. What is the ratio of the Area (% of total land area) of Terrestrial protected areas in 1994 to that in 2000?
Provide a succinct answer. 0.7. What is the ratio of the Area (% of total land area) in Agricultural land in 1994 to that in 2000?
Offer a terse response. 1.01. What is the ratio of the Area (% of total land area) of Arable land in 1994 to that in 2000?
Offer a terse response. 1.01. What is the ratio of the Area (% of total land area) of Permanent crop land in 1994 to that in 2000?
Your response must be concise. 1.07. What is the ratio of the Area (% of total land area) in Terrestrial protected areas in 1995 to that in 1996?
Make the answer very short. 0.92. What is the ratio of the Area (% of total land area) of Arable land in 1995 to that in 1996?
Offer a terse response. 1. What is the ratio of the Area (% of total land area) in Permanent crop land in 1995 to that in 1996?
Provide a short and direct response. 1.01. What is the ratio of the Area (% of total land area) in Terrestrial protected areas in 1995 to that in 1997?
Give a very brief answer. 0.92. What is the ratio of the Area (% of total land area) in Agricultural land in 1995 to that in 1997?
Offer a terse response. 1. What is the ratio of the Area (% of total land area) of Arable land in 1995 to that in 1997?
Offer a very short reply. 1. What is the ratio of the Area (% of total land area) of Permanent crop land in 1995 to that in 1997?
Your answer should be very brief. 1.03. What is the ratio of the Area (% of total land area) of Terrestrial protected areas in 1995 to that in 1998?
Give a very brief answer. 0.91. What is the ratio of the Area (% of total land area) in Agricultural land in 1995 to that in 1998?
Ensure brevity in your answer.  1.01. What is the ratio of the Area (% of total land area) in Permanent crop land in 1995 to that in 1998?
Provide a short and direct response. 1.03. What is the ratio of the Area (% of total land area) in Terrestrial protected areas in 1995 to that in 1999?
Provide a short and direct response. 0.91. What is the ratio of the Area (% of total land area) in Permanent crop land in 1995 to that in 1999?
Keep it short and to the point. 1.04. What is the ratio of the Area (% of total land area) of Terrestrial protected areas in 1995 to that in 2000?
Offer a very short reply. 0.7. What is the ratio of the Area (% of total land area) of Agricultural land in 1995 to that in 2000?
Offer a terse response. 1.01. What is the ratio of the Area (% of total land area) of Arable land in 1995 to that in 2000?
Provide a succinct answer. 1.01. What is the ratio of the Area (% of total land area) in Permanent crop land in 1995 to that in 2000?
Ensure brevity in your answer.  1.06. What is the ratio of the Area (% of total land area) in Agricultural land in 1996 to that in 1997?
Your answer should be very brief. 1. What is the ratio of the Area (% of total land area) in Arable land in 1996 to that in 1997?
Offer a very short reply. 1. What is the ratio of the Area (% of total land area) in Permanent crop land in 1996 to that in 1997?
Make the answer very short. 1.01. What is the ratio of the Area (% of total land area) of Terrestrial protected areas in 1996 to that in 1998?
Keep it short and to the point. 0.99. What is the ratio of the Area (% of total land area) of Agricultural land in 1996 to that in 1998?
Your response must be concise. 1. What is the ratio of the Area (% of total land area) in Permanent crop land in 1996 to that in 1998?
Give a very brief answer. 1.02. What is the ratio of the Area (% of total land area) of Terrestrial protected areas in 1996 to that in 1999?
Ensure brevity in your answer.  0.99. What is the ratio of the Area (% of total land area) in Agricultural land in 1996 to that in 1999?
Your answer should be very brief. 1.01. What is the ratio of the Area (% of total land area) of Permanent crop land in 1996 to that in 1999?
Give a very brief answer. 1.02. What is the ratio of the Area (% of total land area) in Terrestrial protected areas in 1996 to that in 2000?
Offer a very short reply. 0.76. What is the ratio of the Area (% of total land area) in Agricultural land in 1996 to that in 2000?
Your answer should be compact. 1.01. What is the ratio of the Area (% of total land area) of Arable land in 1996 to that in 2000?
Give a very brief answer. 1.01. What is the ratio of the Area (% of total land area) of Permanent crop land in 1996 to that in 2000?
Offer a terse response. 1.04. What is the ratio of the Area (% of total land area) of Terrestrial protected areas in 1997 to that in 1998?
Give a very brief answer. 1. What is the ratio of the Area (% of total land area) of Agricultural land in 1997 to that in 1998?
Keep it short and to the point. 1. What is the ratio of the Area (% of total land area) in Arable land in 1997 to that in 1998?
Provide a succinct answer. 1. What is the ratio of the Area (% of total land area) of Permanent crop land in 1997 to that in 1998?
Offer a very short reply. 1. What is the ratio of the Area (% of total land area) in Agricultural land in 1997 to that in 1999?
Your answer should be very brief. 1. What is the ratio of the Area (% of total land area) in Permanent crop land in 1997 to that in 1999?
Your answer should be compact. 1.01. What is the ratio of the Area (% of total land area) in Terrestrial protected areas in 1997 to that in 2000?
Ensure brevity in your answer.  0.76. What is the ratio of the Area (% of total land area) in Agricultural land in 1997 to that in 2000?
Offer a very short reply. 1.01. What is the ratio of the Area (% of total land area) in Permanent crop land in 1997 to that in 2000?
Offer a very short reply. 1.03. What is the ratio of the Area (% of total land area) of Terrestrial protected areas in 1998 to that in 1999?
Provide a succinct answer. 1. What is the ratio of the Area (% of total land area) of Agricultural land in 1998 to that in 1999?
Your answer should be compact. 1. What is the ratio of the Area (% of total land area) in Arable land in 1998 to that in 1999?
Make the answer very short. 1. What is the ratio of the Area (% of total land area) in Permanent crop land in 1998 to that in 1999?
Give a very brief answer. 1.01. What is the ratio of the Area (% of total land area) of Terrestrial protected areas in 1998 to that in 2000?
Your answer should be compact. 0.76. What is the ratio of the Area (% of total land area) in Permanent crop land in 1998 to that in 2000?
Keep it short and to the point. 1.03. What is the ratio of the Area (% of total land area) of Terrestrial protected areas in 1999 to that in 2000?
Provide a short and direct response. 0.76. What is the ratio of the Area (% of total land area) in Agricultural land in 1999 to that in 2000?
Offer a terse response. 1. What is the ratio of the Area (% of total land area) in Permanent crop land in 1999 to that in 2000?
Your answer should be compact. 1.02. What is the difference between the highest and the second highest Area (% of total land area) in Terrestrial protected areas?
Provide a short and direct response. 1.59. What is the difference between the highest and the second highest Area (% of total land area) of Agricultural land?
Offer a terse response. 0.28. What is the difference between the highest and the second highest Area (% of total land area) of Arable land?
Give a very brief answer. 0.04. What is the difference between the highest and the second highest Area (% of total land area) of Permanent crop land?
Provide a short and direct response. 0.03. What is the difference between the highest and the lowest Area (% of total land area) in Terrestrial protected areas?
Your answer should be very brief. 2.04. What is the difference between the highest and the lowest Area (% of total land area) of Agricultural land?
Keep it short and to the point. 1.05. What is the difference between the highest and the lowest Area (% of total land area) of Arable land?
Give a very brief answer. 0.47. What is the difference between the highest and the lowest Area (% of total land area) in Permanent crop land?
Give a very brief answer. 0.29. 